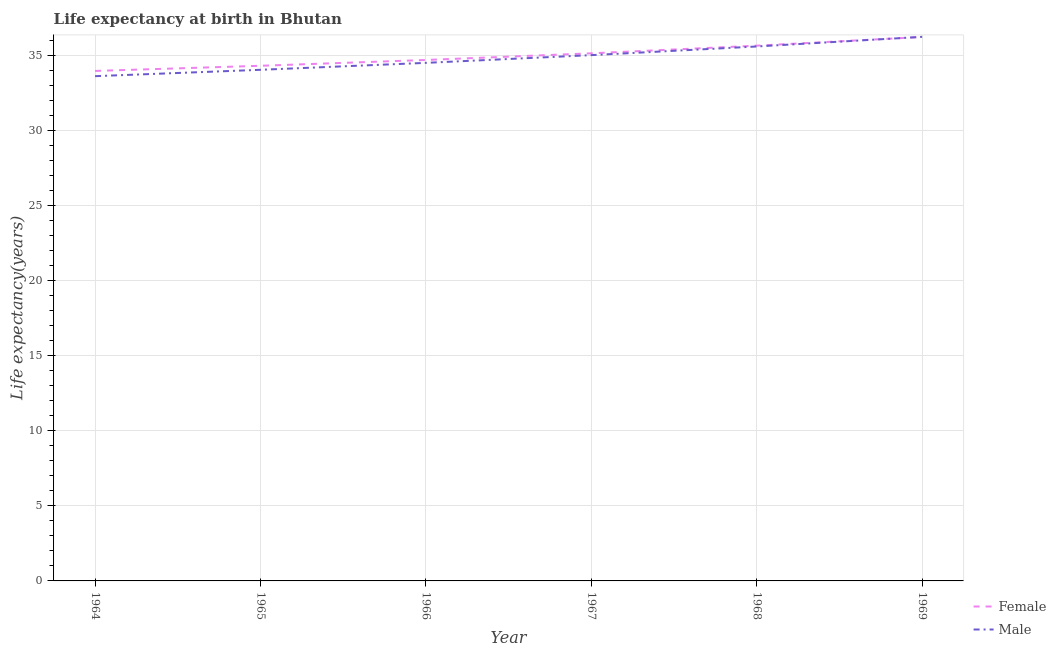How many different coloured lines are there?
Ensure brevity in your answer.  2. What is the life expectancy(male) in 1965?
Provide a succinct answer. 34.07. Across all years, what is the maximum life expectancy(female)?
Provide a succinct answer. 36.26. Across all years, what is the minimum life expectancy(male)?
Provide a short and direct response. 33.65. In which year was the life expectancy(female) maximum?
Offer a very short reply. 1969. In which year was the life expectancy(male) minimum?
Provide a short and direct response. 1964. What is the total life expectancy(male) in the graph?
Your answer should be compact. 209.19. What is the difference between the life expectancy(male) in 1966 and that in 1967?
Keep it short and to the point. -0.52. What is the difference between the life expectancy(female) in 1966 and the life expectancy(male) in 1967?
Ensure brevity in your answer.  -0.32. What is the average life expectancy(female) per year?
Your answer should be very brief. 35.03. In the year 1966, what is the difference between the life expectancy(female) and life expectancy(male)?
Your response must be concise. 0.19. What is the ratio of the life expectancy(female) in 1965 to that in 1968?
Provide a succinct answer. 0.96. Is the life expectancy(female) in 1966 less than that in 1969?
Offer a terse response. Yes. What is the difference between the highest and the second highest life expectancy(female)?
Give a very brief answer. 0.58. What is the difference between the highest and the lowest life expectancy(male)?
Ensure brevity in your answer.  2.62. Is the sum of the life expectancy(female) in 1967 and 1968 greater than the maximum life expectancy(male) across all years?
Your answer should be very brief. Yes. Is the life expectancy(male) strictly greater than the life expectancy(female) over the years?
Offer a very short reply. No. Is the life expectancy(female) strictly less than the life expectancy(male) over the years?
Provide a short and direct response. No. How many lines are there?
Give a very brief answer. 2. How many years are there in the graph?
Provide a succinct answer. 6. Does the graph contain grids?
Provide a succinct answer. Yes. Where does the legend appear in the graph?
Offer a terse response. Bottom right. How are the legend labels stacked?
Your response must be concise. Vertical. What is the title of the graph?
Offer a very short reply. Life expectancy at birth in Bhutan. What is the label or title of the X-axis?
Provide a short and direct response. Year. What is the label or title of the Y-axis?
Provide a short and direct response. Life expectancy(years). What is the Life expectancy(years) in Female in 1964?
Give a very brief answer. 33.99. What is the Life expectancy(years) of Male in 1964?
Your answer should be compact. 33.65. What is the Life expectancy(years) of Female in 1965?
Your answer should be very brief. 34.34. What is the Life expectancy(years) of Male in 1965?
Keep it short and to the point. 34.07. What is the Life expectancy(years) of Female in 1966?
Give a very brief answer. 34.73. What is the Life expectancy(years) in Male in 1966?
Ensure brevity in your answer.  34.53. What is the Life expectancy(years) in Female in 1967?
Offer a terse response. 35.17. What is the Life expectancy(years) of Male in 1967?
Offer a terse response. 35.05. What is the Life expectancy(years) in Female in 1968?
Provide a succinct answer. 35.68. What is the Life expectancy(years) of Male in 1968?
Offer a very short reply. 35.62. What is the Life expectancy(years) of Female in 1969?
Your response must be concise. 36.26. What is the Life expectancy(years) in Male in 1969?
Offer a very short reply. 36.27. Across all years, what is the maximum Life expectancy(years) in Female?
Your answer should be compact. 36.26. Across all years, what is the maximum Life expectancy(years) of Male?
Offer a very short reply. 36.27. Across all years, what is the minimum Life expectancy(years) in Female?
Offer a terse response. 33.99. Across all years, what is the minimum Life expectancy(years) in Male?
Your answer should be compact. 33.65. What is the total Life expectancy(years) in Female in the graph?
Your response must be concise. 210.16. What is the total Life expectancy(years) of Male in the graph?
Ensure brevity in your answer.  209.19. What is the difference between the Life expectancy(years) of Female in 1964 and that in 1965?
Offer a terse response. -0.34. What is the difference between the Life expectancy(years) in Male in 1964 and that in 1965?
Ensure brevity in your answer.  -0.42. What is the difference between the Life expectancy(years) of Female in 1964 and that in 1966?
Offer a terse response. -0.73. What is the difference between the Life expectancy(years) of Male in 1964 and that in 1966?
Keep it short and to the point. -0.89. What is the difference between the Life expectancy(years) of Female in 1964 and that in 1967?
Your answer should be compact. -1.18. What is the difference between the Life expectancy(years) of Male in 1964 and that in 1967?
Keep it short and to the point. -1.4. What is the difference between the Life expectancy(years) in Female in 1964 and that in 1968?
Give a very brief answer. -1.69. What is the difference between the Life expectancy(years) in Male in 1964 and that in 1968?
Offer a very short reply. -1.98. What is the difference between the Life expectancy(years) in Female in 1964 and that in 1969?
Provide a short and direct response. -2.27. What is the difference between the Life expectancy(years) of Male in 1964 and that in 1969?
Provide a short and direct response. -2.62. What is the difference between the Life expectancy(years) in Female in 1965 and that in 1966?
Your response must be concise. -0.39. What is the difference between the Life expectancy(years) in Male in 1965 and that in 1966?
Make the answer very short. -0.46. What is the difference between the Life expectancy(years) in Female in 1965 and that in 1967?
Offer a terse response. -0.83. What is the difference between the Life expectancy(years) of Male in 1965 and that in 1967?
Give a very brief answer. -0.98. What is the difference between the Life expectancy(years) of Female in 1965 and that in 1968?
Your answer should be compact. -1.34. What is the difference between the Life expectancy(years) in Male in 1965 and that in 1968?
Offer a very short reply. -1.55. What is the difference between the Life expectancy(years) of Female in 1965 and that in 1969?
Your response must be concise. -1.92. What is the difference between the Life expectancy(years) in Male in 1965 and that in 1969?
Offer a terse response. -2.2. What is the difference between the Life expectancy(years) of Female in 1966 and that in 1967?
Keep it short and to the point. -0.44. What is the difference between the Life expectancy(years) of Male in 1966 and that in 1967?
Provide a short and direct response. -0.52. What is the difference between the Life expectancy(years) in Female in 1966 and that in 1968?
Make the answer very short. -0.95. What is the difference between the Life expectancy(years) in Male in 1966 and that in 1968?
Make the answer very short. -1.09. What is the difference between the Life expectancy(years) of Female in 1966 and that in 1969?
Your answer should be compact. -1.53. What is the difference between the Life expectancy(years) of Male in 1966 and that in 1969?
Offer a terse response. -1.73. What is the difference between the Life expectancy(years) in Female in 1967 and that in 1968?
Provide a short and direct response. -0.51. What is the difference between the Life expectancy(years) of Male in 1967 and that in 1968?
Your answer should be compact. -0.58. What is the difference between the Life expectancy(years) in Female in 1967 and that in 1969?
Your answer should be very brief. -1.09. What is the difference between the Life expectancy(years) in Male in 1967 and that in 1969?
Provide a succinct answer. -1.22. What is the difference between the Life expectancy(years) of Female in 1968 and that in 1969?
Your answer should be compact. -0.58. What is the difference between the Life expectancy(years) in Male in 1968 and that in 1969?
Provide a short and direct response. -0.64. What is the difference between the Life expectancy(years) in Female in 1964 and the Life expectancy(years) in Male in 1965?
Keep it short and to the point. -0.08. What is the difference between the Life expectancy(years) of Female in 1964 and the Life expectancy(years) of Male in 1966?
Your answer should be compact. -0.54. What is the difference between the Life expectancy(years) in Female in 1964 and the Life expectancy(years) in Male in 1967?
Provide a succinct answer. -1.05. What is the difference between the Life expectancy(years) of Female in 1964 and the Life expectancy(years) of Male in 1968?
Your answer should be compact. -1.63. What is the difference between the Life expectancy(years) in Female in 1964 and the Life expectancy(years) in Male in 1969?
Offer a terse response. -2.27. What is the difference between the Life expectancy(years) in Female in 1965 and the Life expectancy(years) in Male in 1966?
Your answer should be compact. -0.2. What is the difference between the Life expectancy(years) in Female in 1965 and the Life expectancy(years) in Male in 1967?
Make the answer very short. -0.71. What is the difference between the Life expectancy(years) of Female in 1965 and the Life expectancy(years) of Male in 1968?
Ensure brevity in your answer.  -1.29. What is the difference between the Life expectancy(years) of Female in 1965 and the Life expectancy(years) of Male in 1969?
Give a very brief answer. -1.93. What is the difference between the Life expectancy(years) of Female in 1966 and the Life expectancy(years) of Male in 1967?
Offer a very short reply. -0.32. What is the difference between the Life expectancy(years) in Female in 1966 and the Life expectancy(years) in Male in 1968?
Provide a short and direct response. -0.9. What is the difference between the Life expectancy(years) of Female in 1966 and the Life expectancy(years) of Male in 1969?
Provide a short and direct response. -1.54. What is the difference between the Life expectancy(years) in Female in 1967 and the Life expectancy(years) in Male in 1968?
Provide a short and direct response. -0.46. What is the difference between the Life expectancy(years) of Female in 1967 and the Life expectancy(years) of Male in 1969?
Offer a very short reply. -1.1. What is the difference between the Life expectancy(years) of Female in 1968 and the Life expectancy(years) of Male in 1969?
Keep it short and to the point. -0.59. What is the average Life expectancy(years) of Female per year?
Your response must be concise. 35.03. What is the average Life expectancy(years) of Male per year?
Provide a short and direct response. 34.86. In the year 1964, what is the difference between the Life expectancy(years) of Female and Life expectancy(years) of Male?
Make the answer very short. 0.35. In the year 1965, what is the difference between the Life expectancy(years) in Female and Life expectancy(years) in Male?
Offer a very short reply. 0.27. In the year 1966, what is the difference between the Life expectancy(years) in Female and Life expectancy(years) in Male?
Ensure brevity in your answer.  0.19. In the year 1967, what is the difference between the Life expectancy(years) of Female and Life expectancy(years) of Male?
Offer a terse response. 0.12. In the year 1968, what is the difference between the Life expectancy(years) in Female and Life expectancy(years) in Male?
Your answer should be very brief. 0.05. In the year 1969, what is the difference between the Life expectancy(years) of Female and Life expectancy(years) of Male?
Your answer should be compact. -0.01. What is the ratio of the Life expectancy(years) of Male in 1964 to that in 1965?
Provide a succinct answer. 0.99. What is the ratio of the Life expectancy(years) of Female in 1964 to that in 1966?
Your answer should be very brief. 0.98. What is the ratio of the Life expectancy(years) of Male in 1964 to that in 1966?
Provide a short and direct response. 0.97. What is the ratio of the Life expectancy(years) of Female in 1964 to that in 1967?
Provide a succinct answer. 0.97. What is the ratio of the Life expectancy(years) in Female in 1964 to that in 1968?
Offer a terse response. 0.95. What is the ratio of the Life expectancy(years) of Male in 1964 to that in 1968?
Keep it short and to the point. 0.94. What is the ratio of the Life expectancy(years) in Female in 1964 to that in 1969?
Your answer should be compact. 0.94. What is the ratio of the Life expectancy(years) in Male in 1964 to that in 1969?
Your answer should be compact. 0.93. What is the ratio of the Life expectancy(years) of Female in 1965 to that in 1966?
Offer a very short reply. 0.99. What is the ratio of the Life expectancy(years) of Male in 1965 to that in 1966?
Your answer should be compact. 0.99. What is the ratio of the Life expectancy(years) in Female in 1965 to that in 1967?
Offer a very short reply. 0.98. What is the ratio of the Life expectancy(years) of Male in 1965 to that in 1967?
Your answer should be very brief. 0.97. What is the ratio of the Life expectancy(years) in Female in 1965 to that in 1968?
Keep it short and to the point. 0.96. What is the ratio of the Life expectancy(years) in Male in 1965 to that in 1968?
Offer a very short reply. 0.96. What is the ratio of the Life expectancy(years) in Female in 1965 to that in 1969?
Offer a very short reply. 0.95. What is the ratio of the Life expectancy(years) in Male in 1965 to that in 1969?
Offer a terse response. 0.94. What is the ratio of the Life expectancy(years) of Female in 1966 to that in 1967?
Give a very brief answer. 0.99. What is the ratio of the Life expectancy(years) of Female in 1966 to that in 1968?
Keep it short and to the point. 0.97. What is the ratio of the Life expectancy(years) in Male in 1966 to that in 1968?
Provide a short and direct response. 0.97. What is the ratio of the Life expectancy(years) of Female in 1966 to that in 1969?
Give a very brief answer. 0.96. What is the ratio of the Life expectancy(years) of Male in 1966 to that in 1969?
Make the answer very short. 0.95. What is the ratio of the Life expectancy(years) of Female in 1967 to that in 1968?
Offer a very short reply. 0.99. What is the ratio of the Life expectancy(years) of Male in 1967 to that in 1968?
Provide a succinct answer. 0.98. What is the ratio of the Life expectancy(years) in Female in 1967 to that in 1969?
Your response must be concise. 0.97. What is the ratio of the Life expectancy(years) in Male in 1967 to that in 1969?
Provide a succinct answer. 0.97. What is the ratio of the Life expectancy(years) in Female in 1968 to that in 1969?
Offer a terse response. 0.98. What is the ratio of the Life expectancy(years) of Male in 1968 to that in 1969?
Your answer should be very brief. 0.98. What is the difference between the highest and the second highest Life expectancy(years) in Female?
Offer a very short reply. 0.58. What is the difference between the highest and the second highest Life expectancy(years) of Male?
Keep it short and to the point. 0.64. What is the difference between the highest and the lowest Life expectancy(years) in Female?
Offer a very short reply. 2.27. What is the difference between the highest and the lowest Life expectancy(years) of Male?
Your answer should be compact. 2.62. 